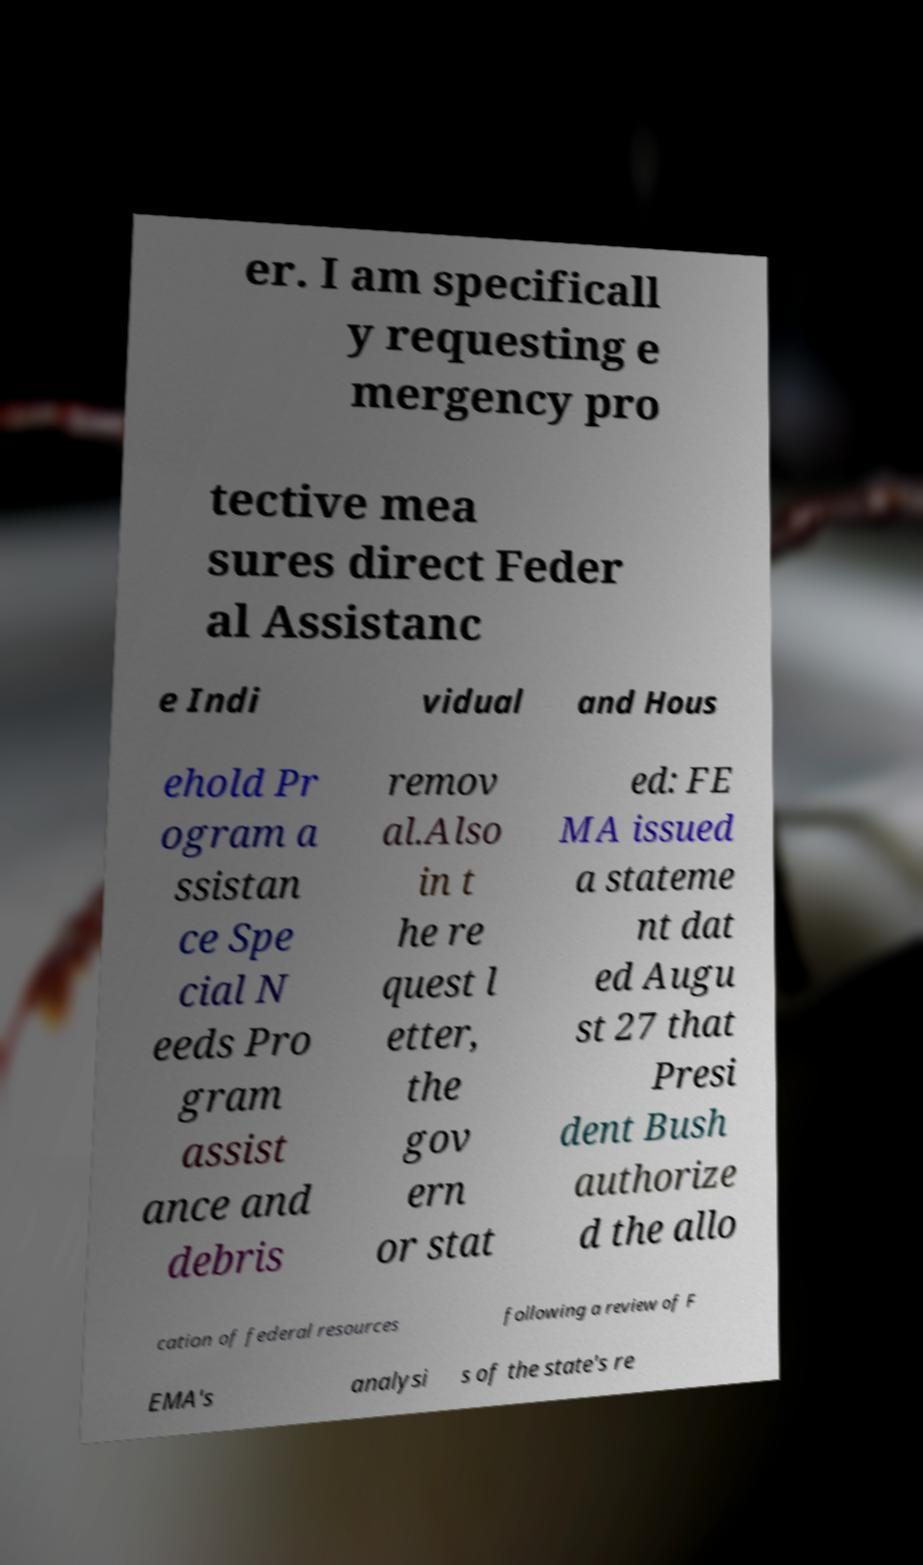I need the written content from this picture converted into text. Can you do that? er. I am specificall y requesting e mergency pro tective mea sures direct Feder al Assistanc e Indi vidual and Hous ehold Pr ogram a ssistan ce Spe cial N eeds Pro gram assist ance and debris remov al.Also in t he re quest l etter, the gov ern or stat ed: FE MA issued a stateme nt dat ed Augu st 27 that Presi dent Bush authorize d the allo cation of federal resources following a review of F EMA's analysi s of the state's re 